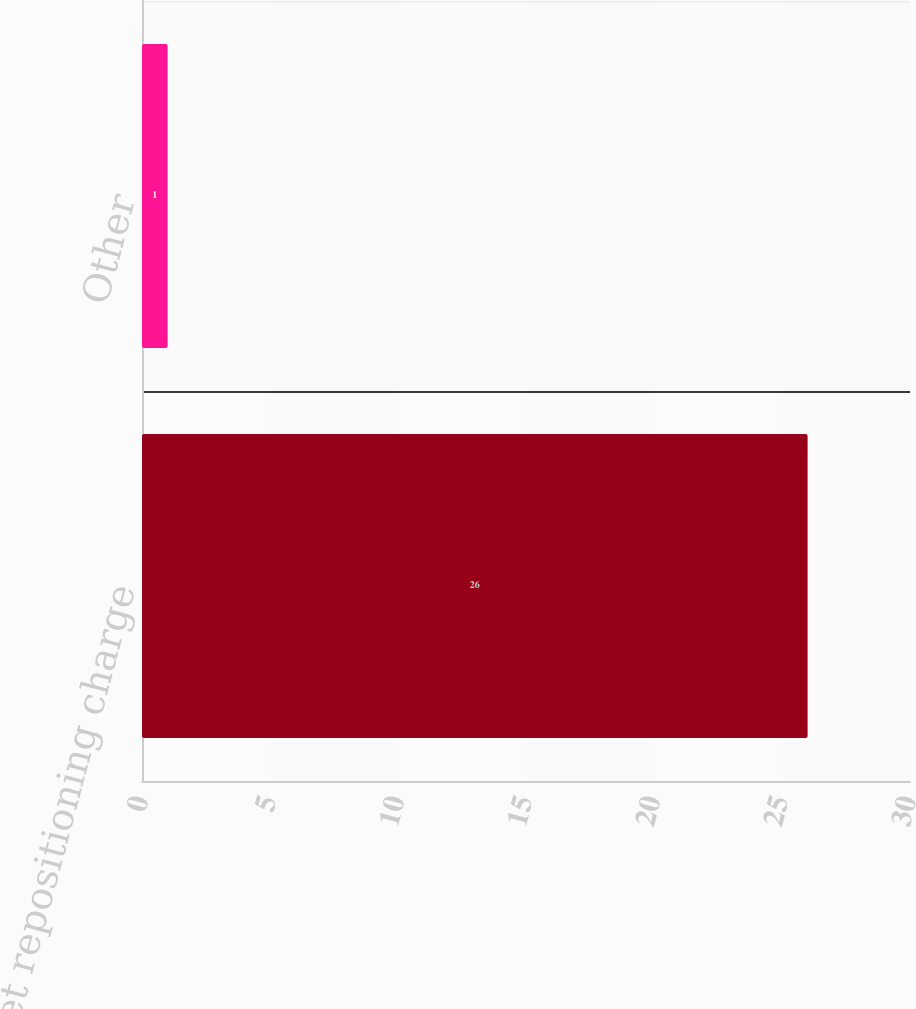<chart> <loc_0><loc_0><loc_500><loc_500><bar_chart><fcel>Net repositioning charge<fcel>Other<nl><fcel>26<fcel>1<nl></chart> 